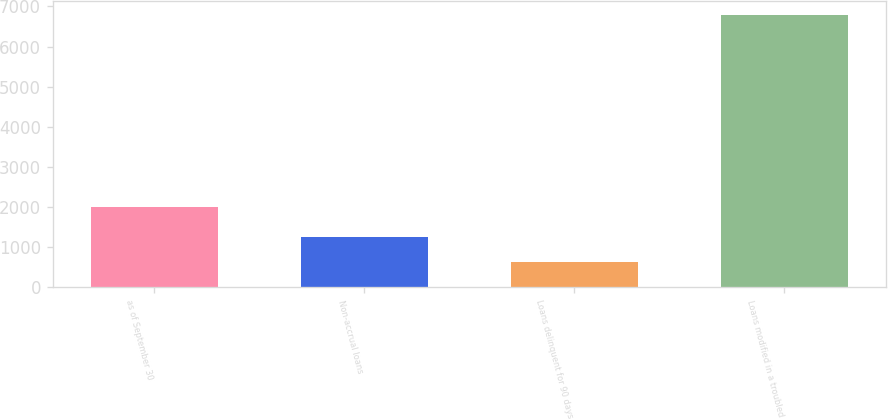Convert chart to OTSL. <chart><loc_0><loc_0><loc_500><loc_500><bar_chart><fcel>as of September 30<fcel>Non-accrual loans<fcel>Loans delinquent for 90 days<fcel>Loans modified in a troubled<nl><fcel>2009<fcel>1256.9<fcel>642<fcel>6791<nl></chart> 